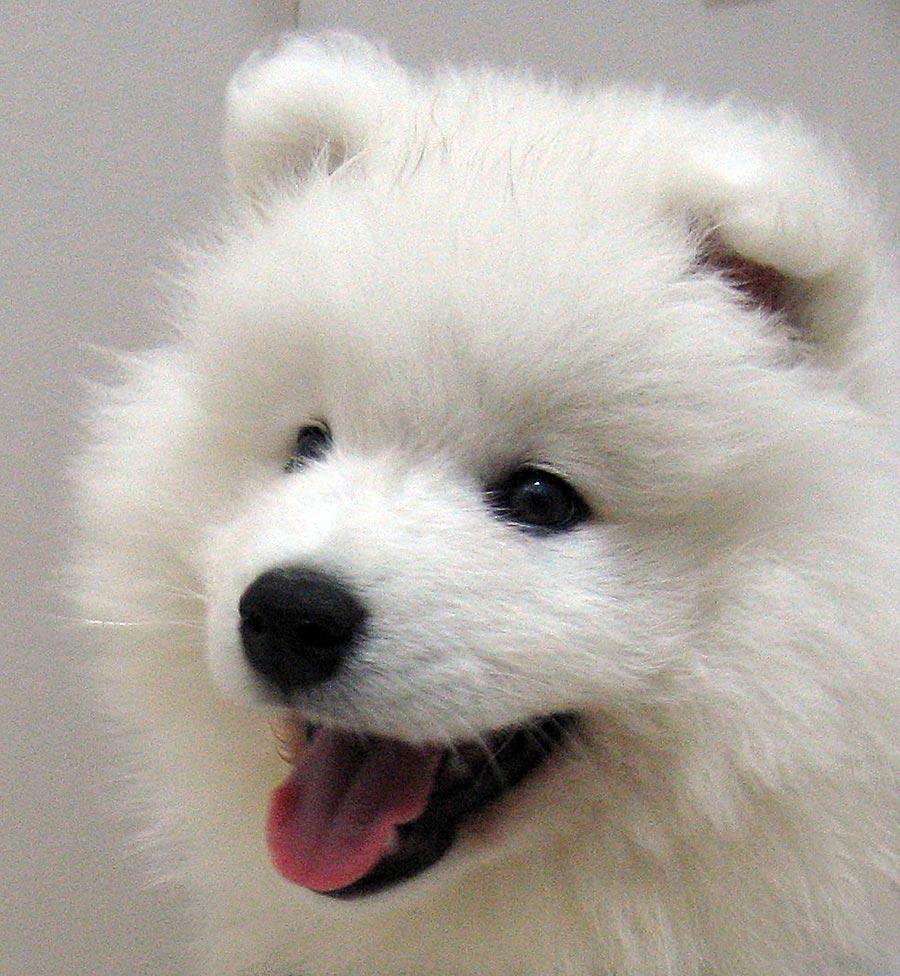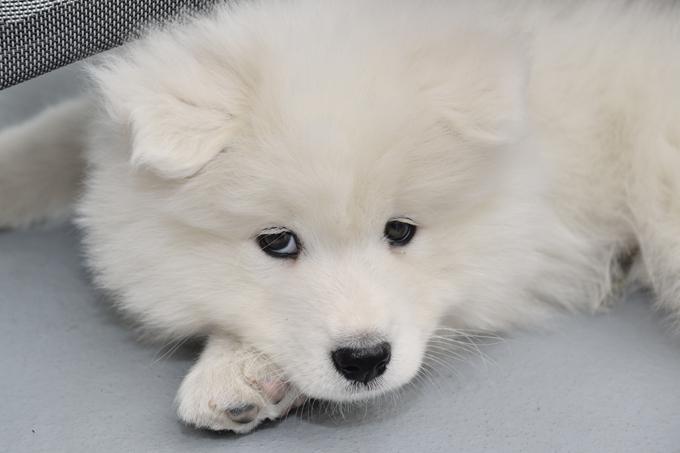The first image is the image on the left, the second image is the image on the right. Assess this claim about the two images: "There are at most 2 dogs in the image pair". Correct or not? Answer yes or no. Yes. The first image is the image on the left, the second image is the image on the right. Analyze the images presented: Is the assertion "The dog in the left photo has its tongue out." valid? Answer yes or no. Yes. The first image is the image on the left, the second image is the image on the right. Assess this claim about the two images: "At least one image shows a white dog standing on all fours in the grass.". Correct or not? Answer yes or no. No. The first image is the image on the left, the second image is the image on the right. For the images displayed, is the sentence "There are at most two dogs." factually correct? Answer yes or no. Yes. 